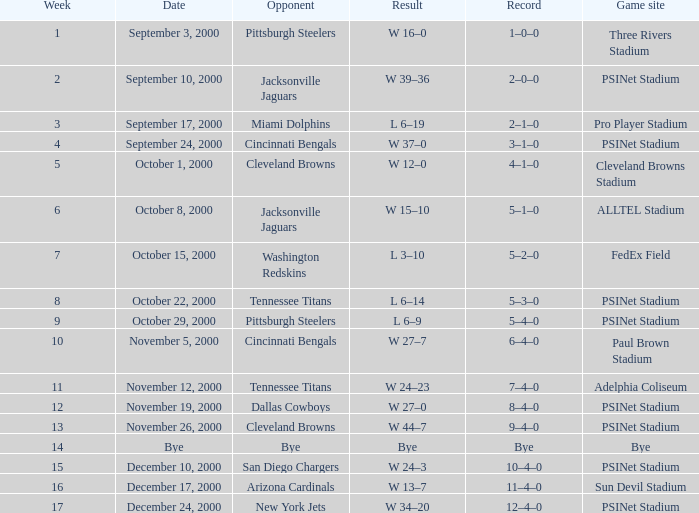What's the result at psinet stadium when the cincinnati bengals are the opponent? W 37–0. 